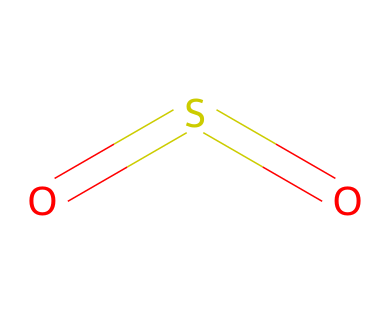What is the molecular formula of this chemical? The SMILES representation indicates that there are two oxygen atoms and one sulfur atom connected in a particular arrangement. The count of these atoms forms the molecular formula, which is SO2 for sulfur dioxide.
Answer: SO2 How many double bonds are present in this structure? The structure based on the SMILES includes two sulfur-oxygen connections, both of which are double bonds. Therefore, there are two double bonds in total.
Answer: 2 What is the molecular geometry of this compound? Sulfur dioxide, with its two double bonds and a lone pair on sulfur, exhibits a bent or V-shape molecular geometry due to the repulsion between the lone pair and the bonding pairs.
Answer: bent What type of bonding is present in this chemical? The presence of double bonds between sulfur and oxygen atoms indicates that the bonding in this compound is covalent. Covalent bonds are formed when atoms share electrons, which is characteristic of the bonds seen here.
Answer: covalent Is this compound considered an air pollutant? Sulfur dioxide (SO2) is widely recognized for its environmental impact and is classified as a major air pollutant, primarily due to its association with industrial emissions and vehicle exhaust.
Answer: yes What type of organosulfur compound is SO2? Sulfur dioxide is classified as a simple organosulfur compound, which refers to compounds that contain sulfur and are linked with organic chemistry contexts, though it is primarily known for its role as an inorganic compound due to its environmental implications.
Answer: simple organosulfur compound 